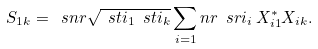Convert formula to latex. <formula><loc_0><loc_0><loc_500><loc_500>S _ { 1 k } = \ s n r \sqrt { \ s t i _ { 1 } \ s t i _ { k } } \sum _ { i = 1 } ^ { \ } n r \ s r i _ { i } \, { X } _ { i 1 } ^ { * } X _ { i k } .</formula> 